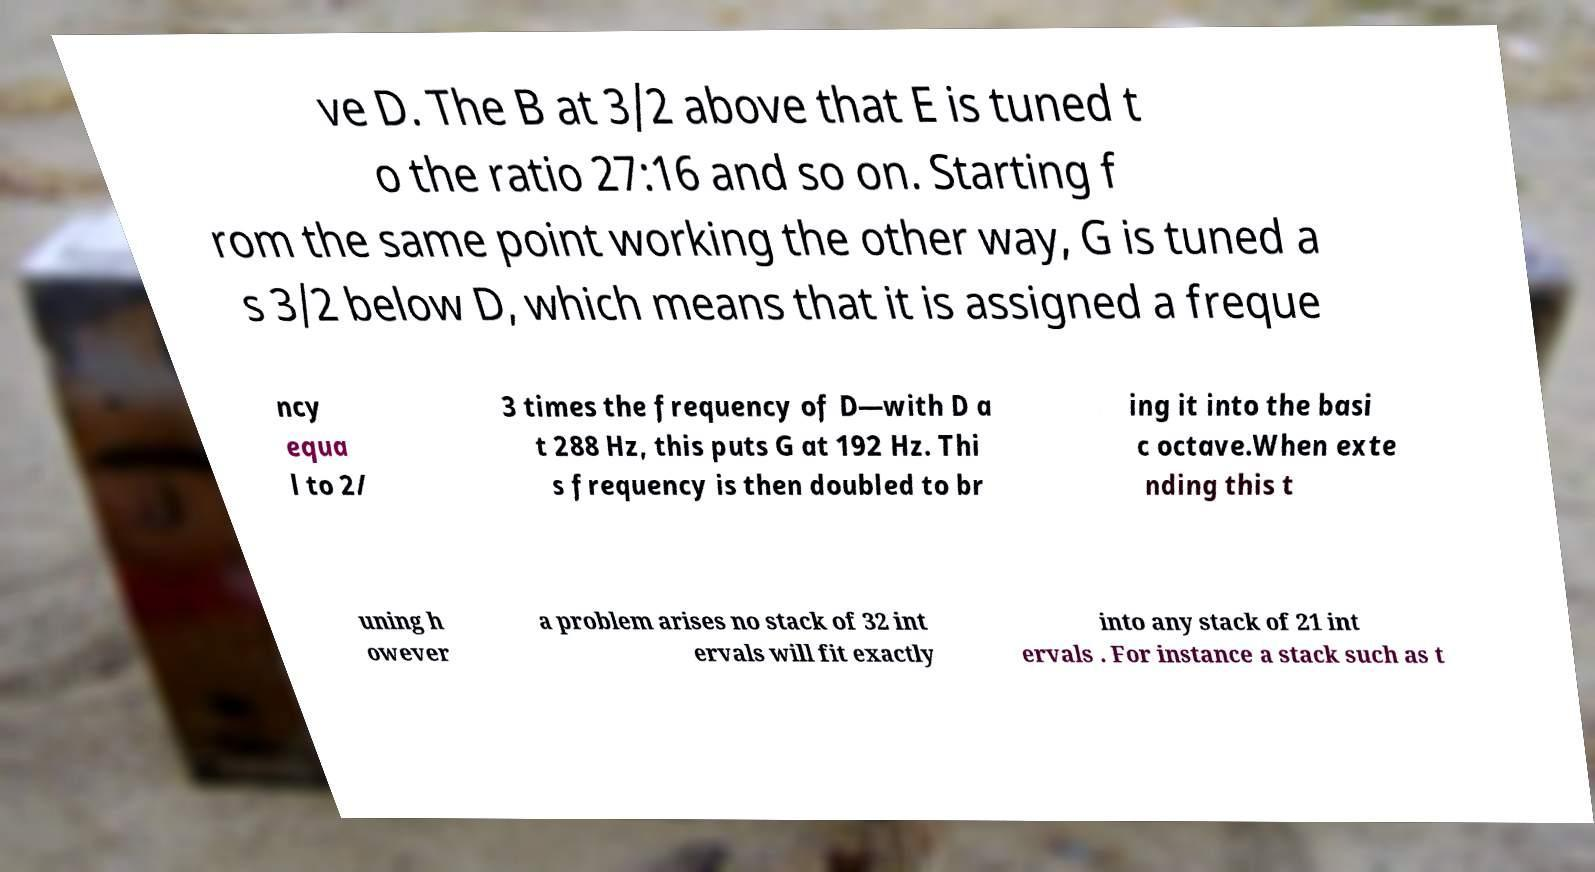I need the written content from this picture converted into text. Can you do that? ve D. The B at 3/2 above that E is tuned t o the ratio 27:16 and so on. Starting f rom the same point working the other way, G is tuned a s 3/2 below D, which means that it is assigned a freque ncy equa l to 2/ 3 times the frequency of D—with D a t 288 Hz, this puts G at 192 Hz. Thi s frequency is then doubled to br ing it into the basi c octave.When exte nding this t uning h owever a problem arises no stack of 32 int ervals will fit exactly into any stack of 21 int ervals . For instance a stack such as t 